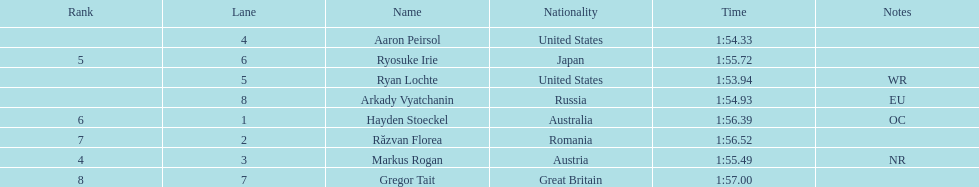How many swimmers were from the us? 2. 